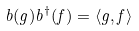<formula> <loc_0><loc_0><loc_500><loc_500>b ( g ) b ^ { \dagger } ( f ) = \langle g , f \rangle</formula> 